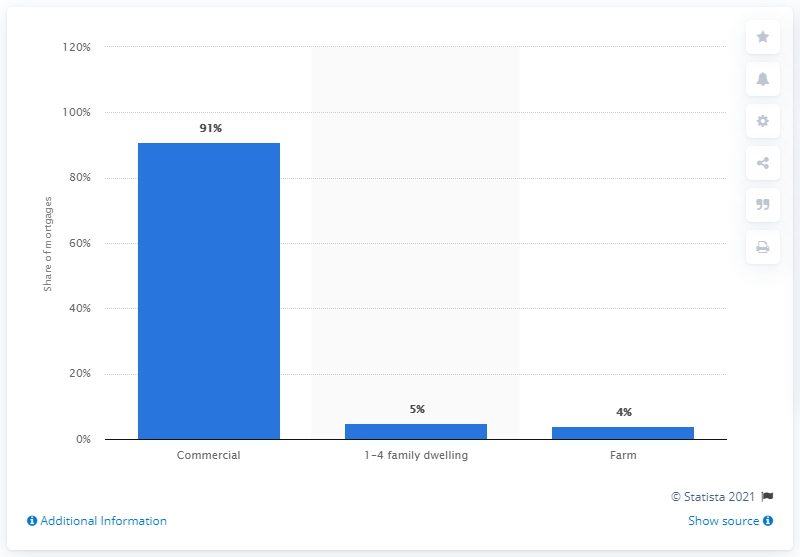Mention a couple of crucial points in this snapshot. In 2018, 91% of all mortgages held by U.S. life insurers were commercial mortgages. 